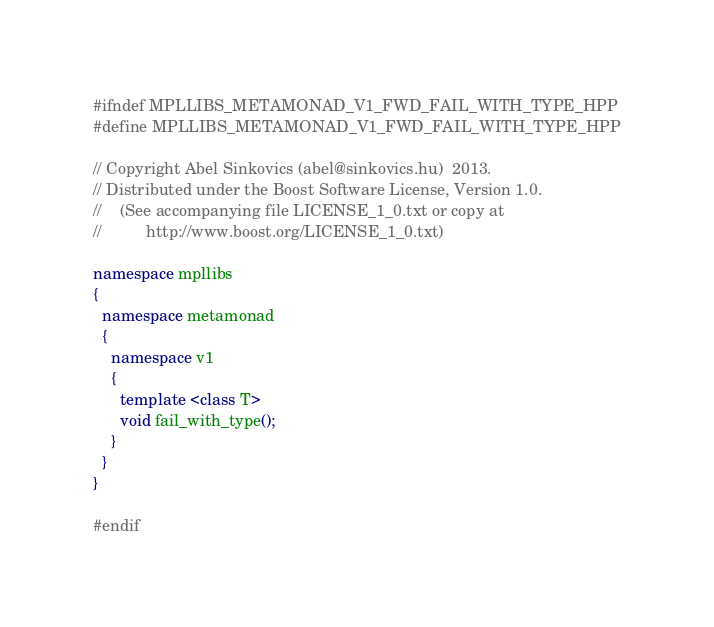Convert code to text. <code><loc_0><loc_0><loc_500><loc_500><_C++_>#ifndef MPLLIBS_METAMONAD_V1_FWD_FAIL_WITH_TYPE_HPP
#define MPLLIBS_METAMONAD_V1_FWD_FAIL_WITH_TYPE_HPP

// Copyright Abel Sinkovics (abel@sinkovics.hu)  2013.
// Distributed under the Boost Software License, Version 1.0.
//    (See accompanying file LICENSE_1_0.txt or copy at
//          http://www.boost.org/LICENSE_1_0.txt)

namespace mpllibs
{
  namespace metamonad
  {
    namespace v1
    {
      template <class T>
      void fail_with_type();
    }
  }
}

#endif

</code> 